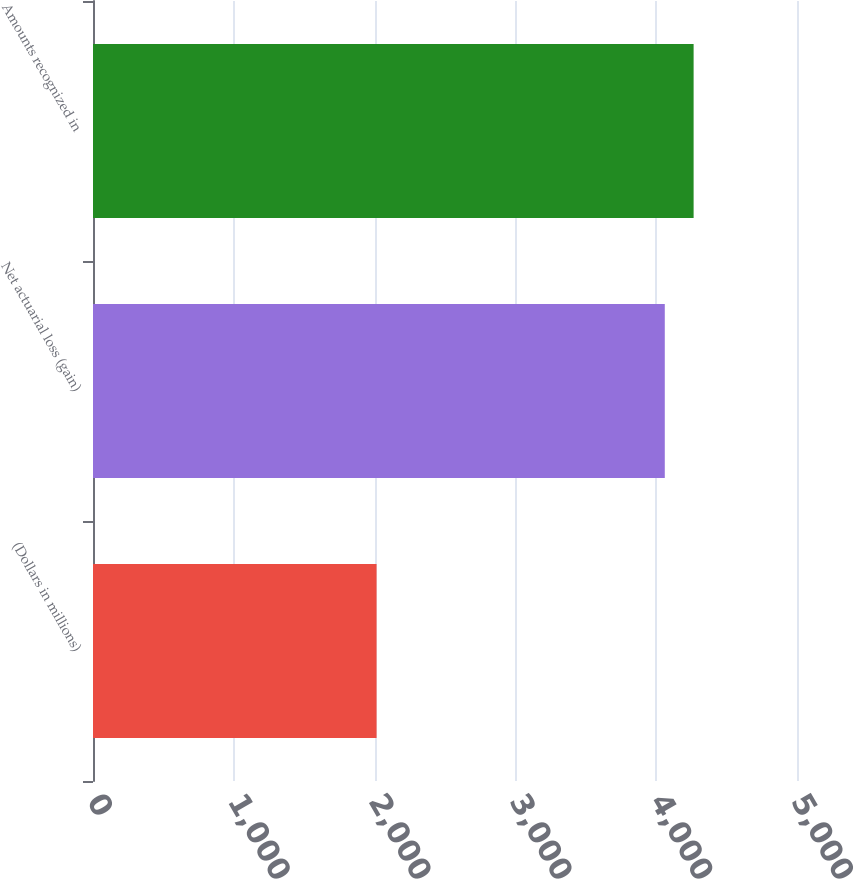Convert chart to OTSL. <chart><loc_0><loc_0><loc_500><loc_500><bar_chart><fcel>(Dollars in millions)<fcel>Net actuarial loss (gain)<fcel>Amounts recognized in<nl><fcel>2014<fcel>4061<fcel>4265.7<nl></chart> 